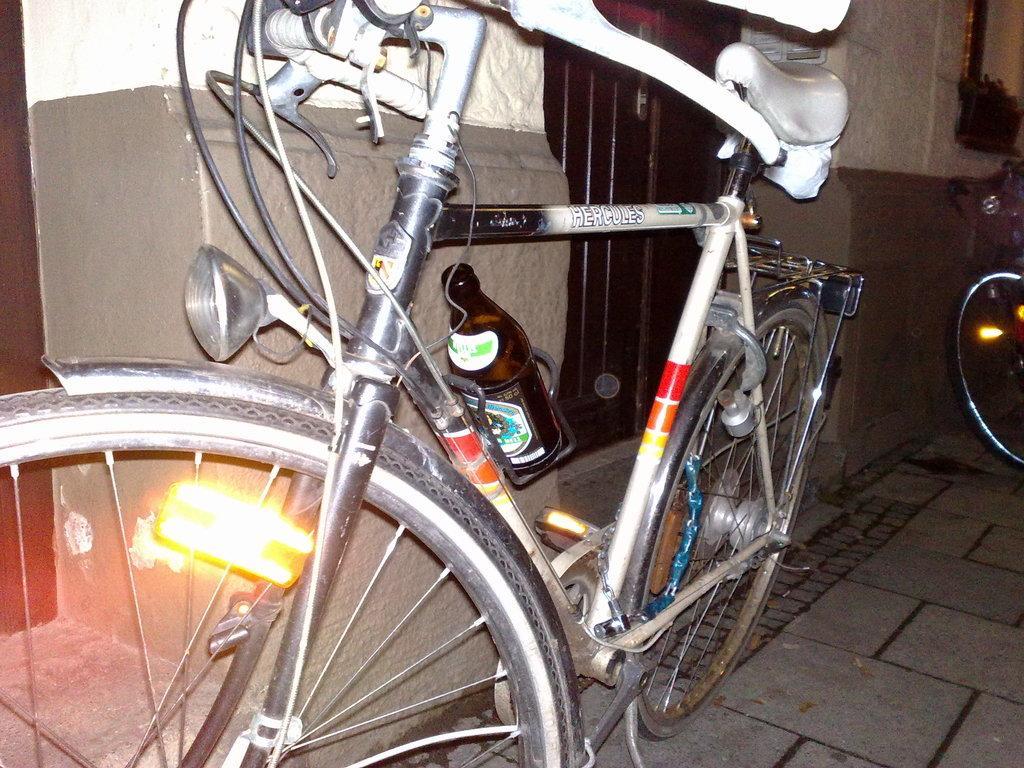In one or two sentences, can you explain what this image depicts? In this image we can see bicycles on the floor. In the background, we can see a window and a wall. We can see a bottle is attached to one bicycle. 